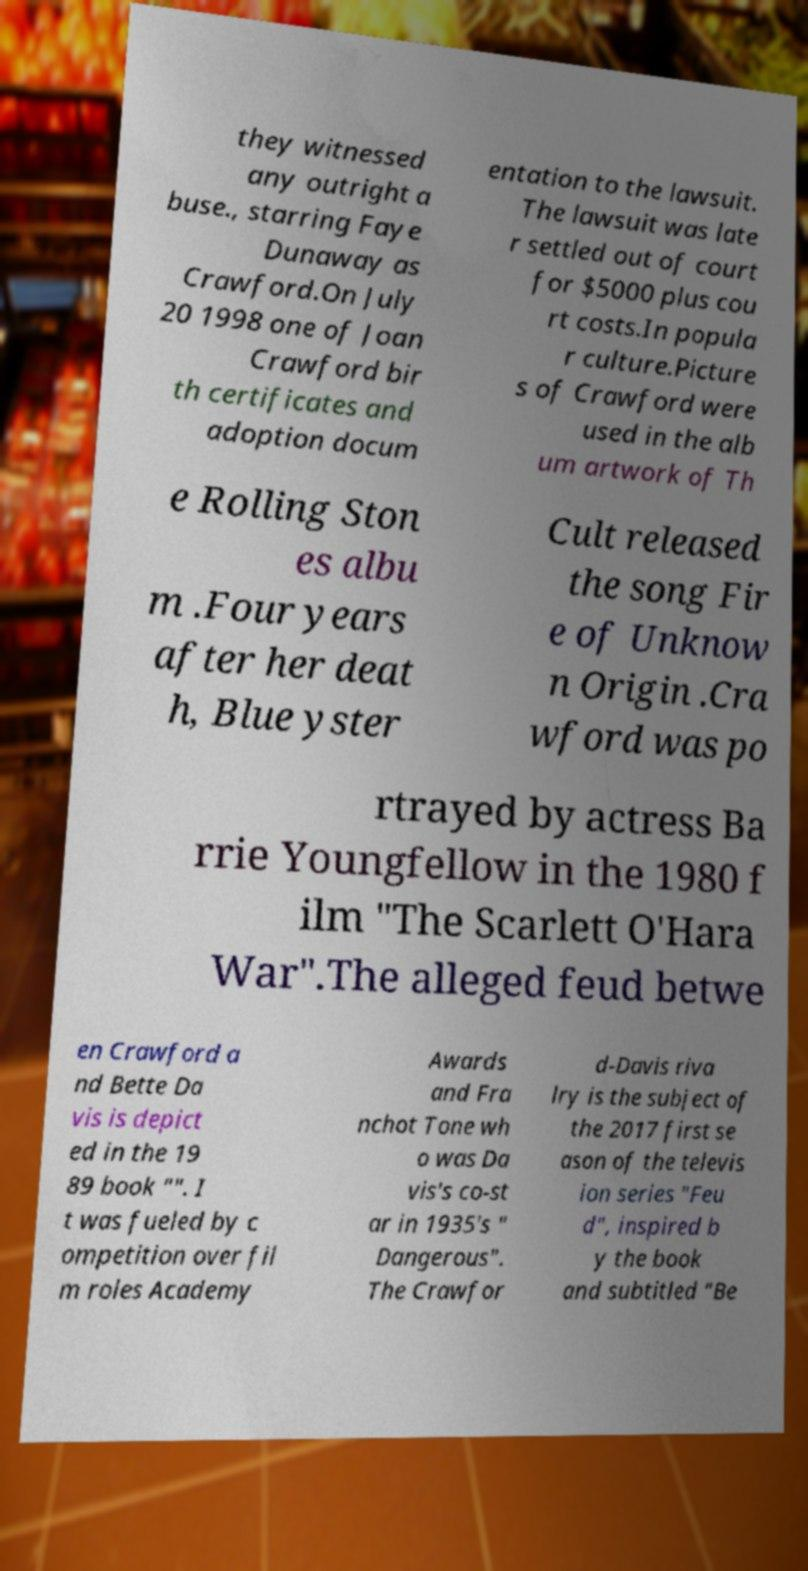Can you accurately transcribe the text from the provided image for me? they witnessed any outright a buse., starring Faye Dunaway as Crawford.On July 20 1998 one of Joan Crawford bir th certificates and adoption docum entation to the lawsuit. The lawsuit was late r settled out of court for $5000 plus cou rt costs.In popula r culture.Picture s of Crawford were used in the alb um artwork of Th e Rolling Ston es albu m .Four years after her deat h, Blue yster Cult released the song Fir e of Unknow n Origin .Cra wford was po rtrayed by actress Ba rrie Youngfellow in the 1980 f ilm "The Scarlett O'Hara War".The alleged feud betwe en Crawford a nd Bette Da vis is depict ed in the 19 89 book "". I t was fueled by c ompetition over fil m roles Academy Awards and Fra nchot Tone wh o was Da vis's co-st ar in 1935's " Dangerous". The Crawfor d-Davis riva lry is the subject of the 2017 first se ason of the televis ion series "Feu d", inspired b y the book and subtitled "Be 